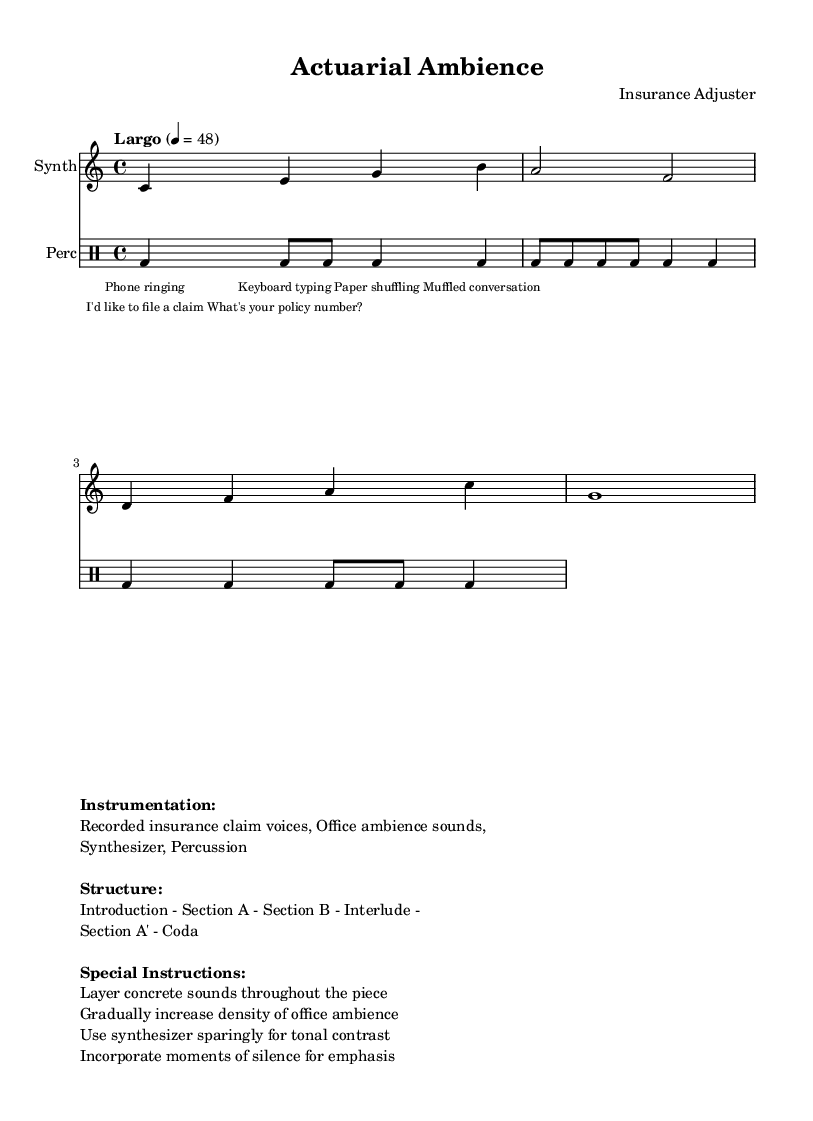What is the key signature of this music? The key signature is C major, which indicates that there are no sharps or flats in the piece. This is found at the beginning of the staff notation where key signatures are indicated.
Answer: C major What is the time signature of this music? The time signature is 4/4, meaning there are four beats in each measure and the quarter note gets one beat. This is typically denoted at the beginning of a piece.
Answer: 4/4 What is the tempo marking given in the score? The tempo marking is "Largo," which indicates a very slow pace. It is denoted near the beginning of the piece, affecting the overall feel of the composition.
Answer: Largo How many sections are indicated in the structure of the composition? The structure of the composition includes six sections: Introduction, Section A, Section B, Interlude, Section A', and Coda. This information is provided in the markup section outlining the composition's form.
Answer: 6 What are the concrete sounds incorporated into the piece? The concrete sounds include recorded insurance claim voices and office ambience sounds, as mentioned in the instrumentation section of the markup.
Answer: Recorded insurance claim voices, Office ambience sounds What is the instruction regarding the density of office ambience? The instruction is to gradually increase the density of office ambience throughout the piece. This indicates how the composer intends to change the texture of the soundscape over time.
Answer: Gradually increase density of office ambience What is the function of silence in this piece? The instruction specifies to incorporate moments of silence for emphasis, which serves to create contrast and highlight certain aspects of the sound, enhancing the listening experience.
Answer: Incorporate moments of silence for emphasis 